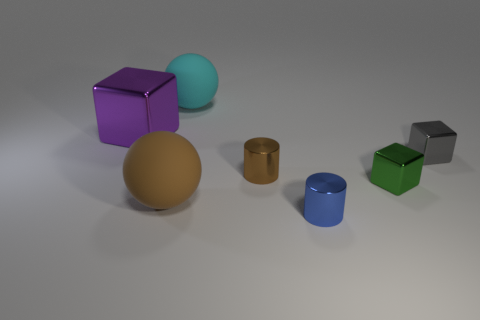Add 2 green shiny cylinders. How many objects exist? 9 Subtract all cubes. How many objects are left? 4 Add 1 red spheres. How many red spheres exist? 1 Subtract 1 cyan spheres. How many objects are left? 6 Subtract all blue matte spheres. Subtract all tiny gray blocks. How many objects are left? 6 Add 6 large matte balls. How many large matte balls are left? 8 